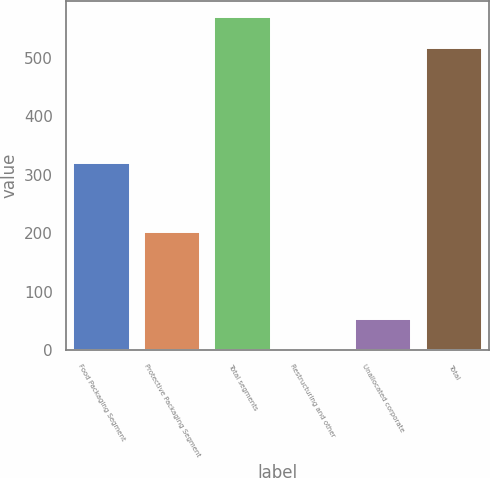Convert chart to OTSL. <chart><loc_0><loc_0><loc_500><loc_500><bar_chart><fcel>Food Packaging Segment<fcel>Protective Packaging Segment<fcel>Total segments<fcel>Restructuring and other<fcel>Unallocated corporate<fcel>Total<nl><fcel>320.6<fcel>202.7<fcel>569.2<fcel>1.3<fcel>53.5<fcel>517<nl></chart> 